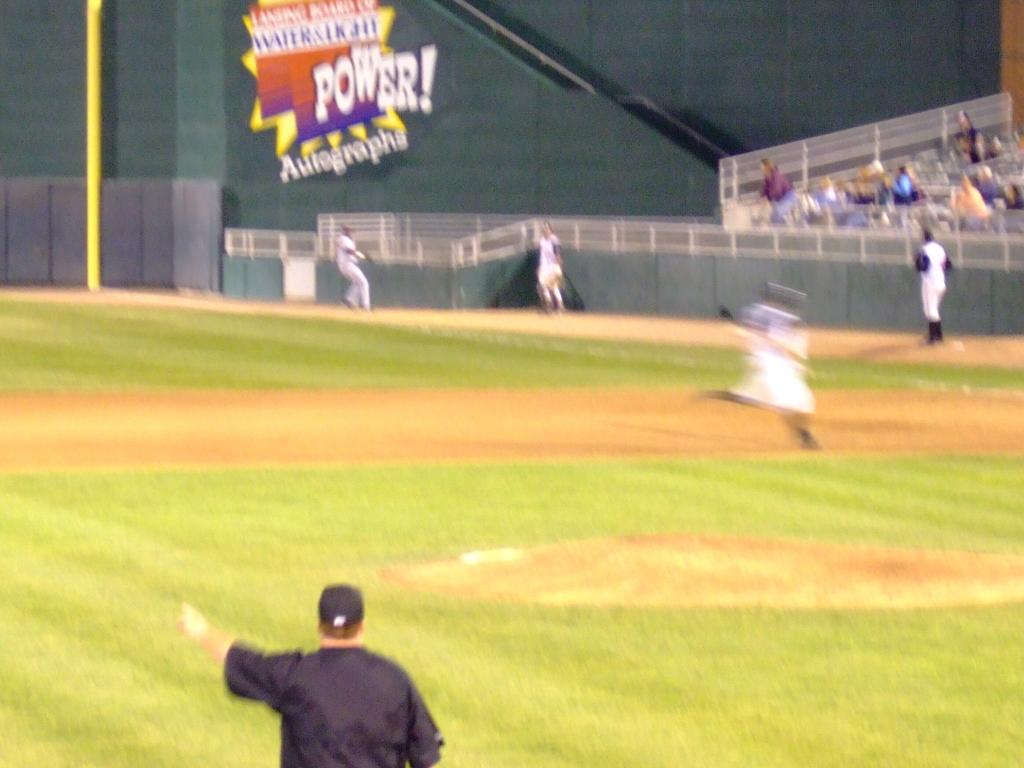<image>
Write a terse but informative summary of the picture. Players play baseball in front of a big sign that says POWER! 